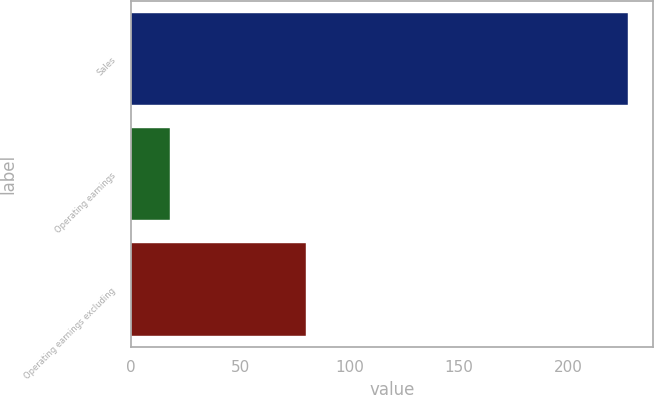<chart> <loc_0><loc_0><loc_500><loc_500><bar_chart><fcel>Sales<fcel>Operating earnings<fcel>Operating earnings excluding<nl><fcel>227<fcel>18<fcel>80<nl></chart> 